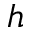<formula> <loc_0><loc_0><loc_500><loc_500>h</formula> 